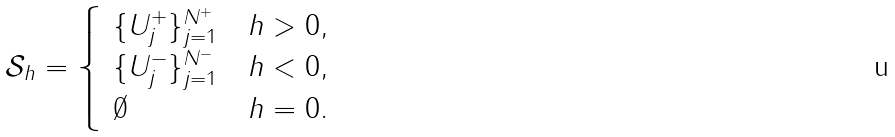Convert formula to latex. <formula><loc_0><loc_0><loc_500><loc_500>{ \mathcal { S } } _ { h } = \begin{cases} \ \{ U _ { j } ^ { + } \} _ { j = 1 } ^ { N ^ { + } } & h > 0 , \\ \ \{ U _ { j } ^ { - } \} _ { j = 1 } ^ { N ^ { - } } & h < 0 , \\ \ \emptyset & h = 0 . \end{cases}</formula> 